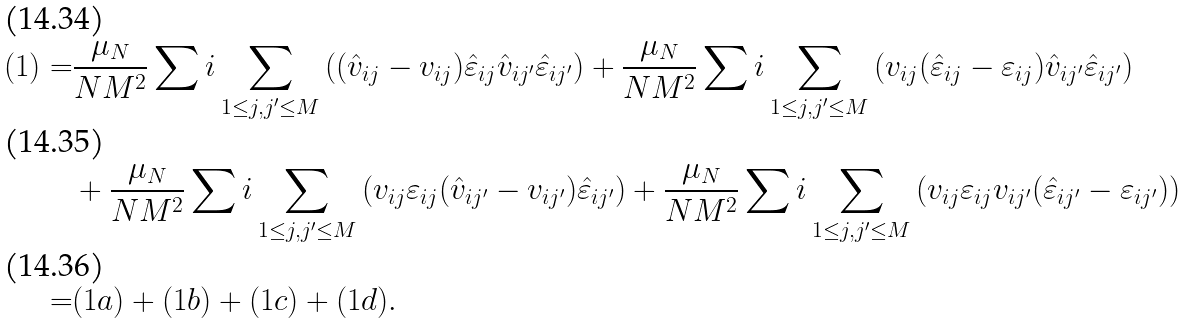<formula> <loc_0><loc_0><loc_500><loc_500>( 1 ) = & \frac { \mu _ { N } } { N M ^ { 2 } } \sum i \sum _ { 1 \leq j , j ^ { \prime } \leq M } \left ( ( \hat { v } _ { i j } - v _ { i j } ) \hat { \varepsilon } _ { i j } \hat { v } _ { i j ^ { \prime } } \hat { \varepsilon } _ { i j ^ { \prime } } \right ) + \frac { \mu _ { N } } { N M ^ { 2 } } \sum i \sum _ { 1 \leq j , j ^ { \prime } \leq M } \left ( v _ { i j } ( \hat { \varepsilon } _ { i j } - \varepsilon _ { i j } ) \hat { v } _ { i j ^ { \prime } } \hat { \varepsilon } _ { i j ^ { \prime } } \right ) \\ & + \frac { \mu _ { N } } { N M ^ { 2 } } \sum i \sum _ { 1 \leq j , j ^ { \prime } \leq M } \left ( v _ { i j } \varepsilon _ { i j } ( \hat { v } _ { i j ^ { \prime } } - v _ { i j ^ { \prime } } ) \hat { \varepsilon } _ { i j ^ { \prime } } \right ) + \frac { \mu _ { N } } { N M ^ { 2 } } \sum i \sum _ { 1 \leq j , j ^ { \prime } \leq M } \left ( v _ { i j } \varepsilon _ { i j } v _ { i j ^ { \prime } } ( \hat { \varepsilon } _ { i j ^ { \prime } } - \varepsilon _ { i j ^ { \prime } } ) \right ) \\ = & ( 1 a ) + ( 1 b ) + ( 1 c ) + ( 1 d ) .</formula> 